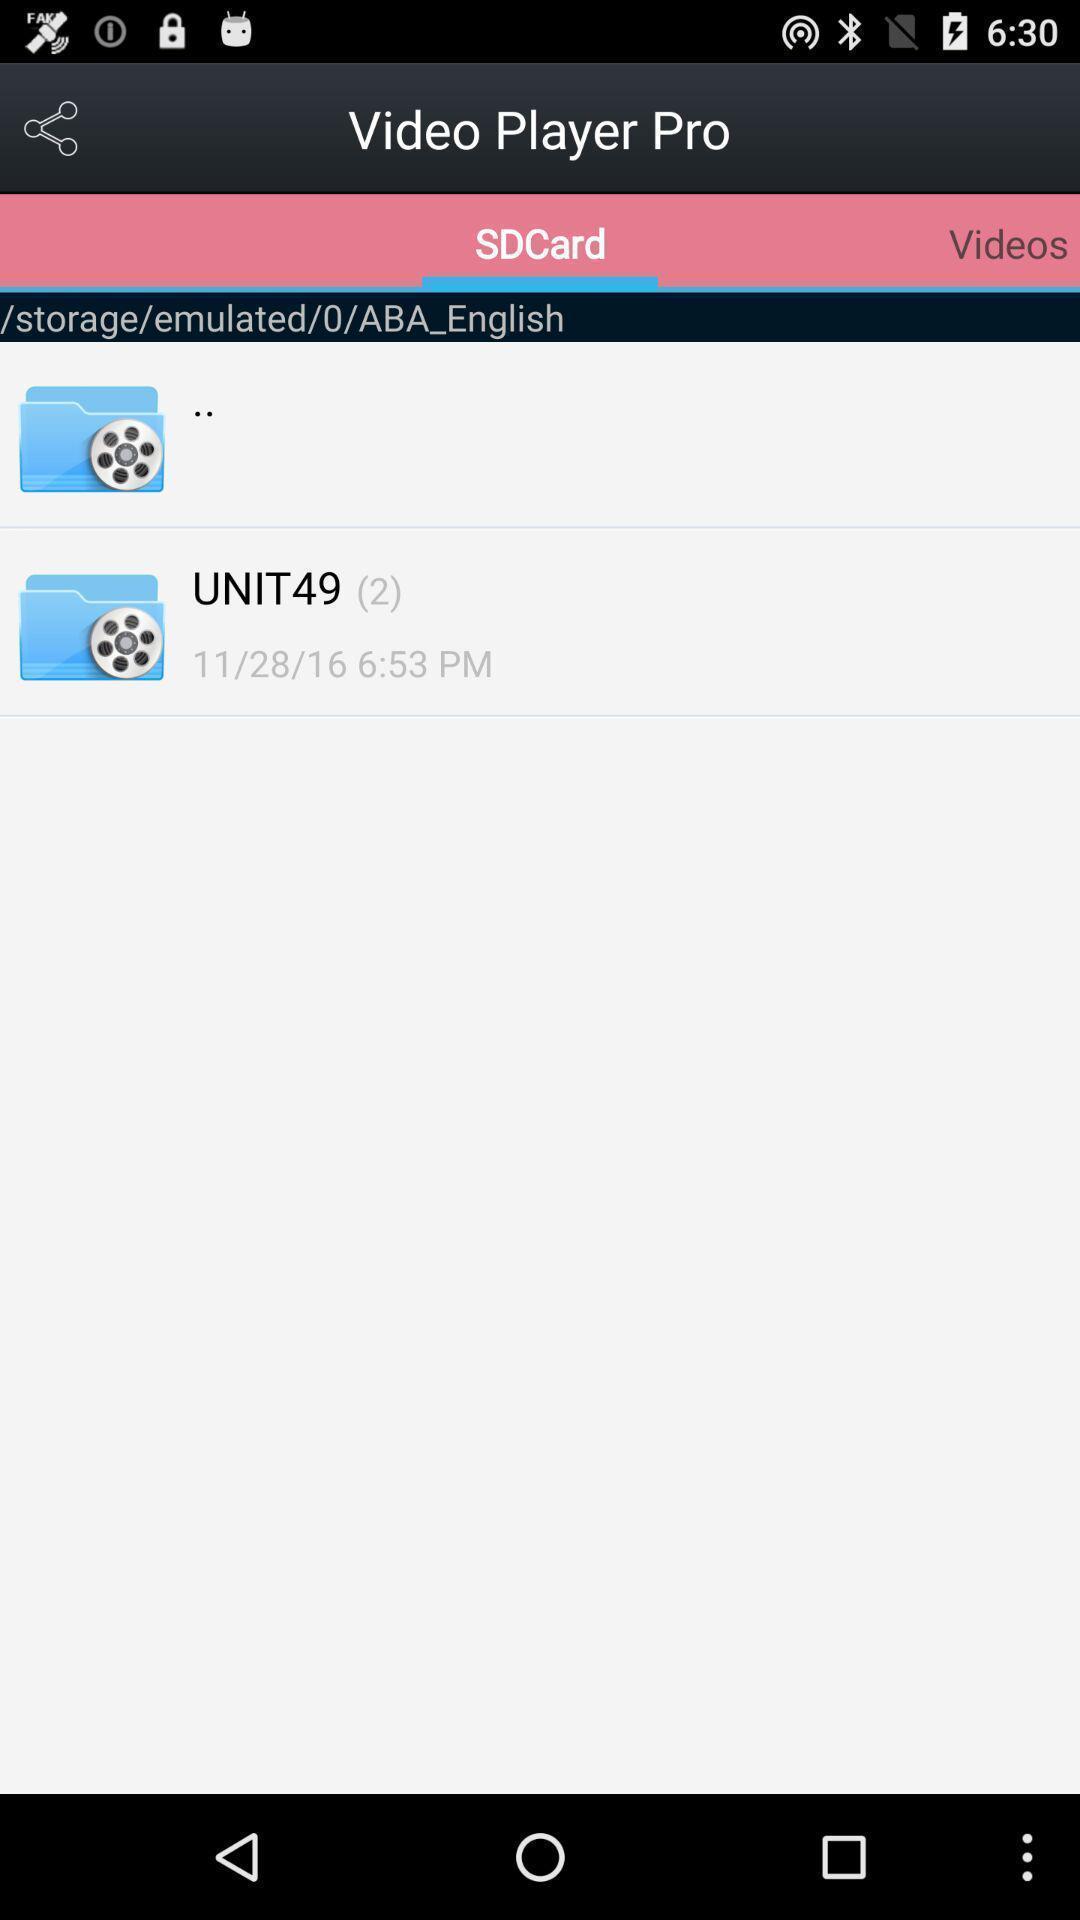Summarize the information in this screenshot. Sd card in video player pro. 